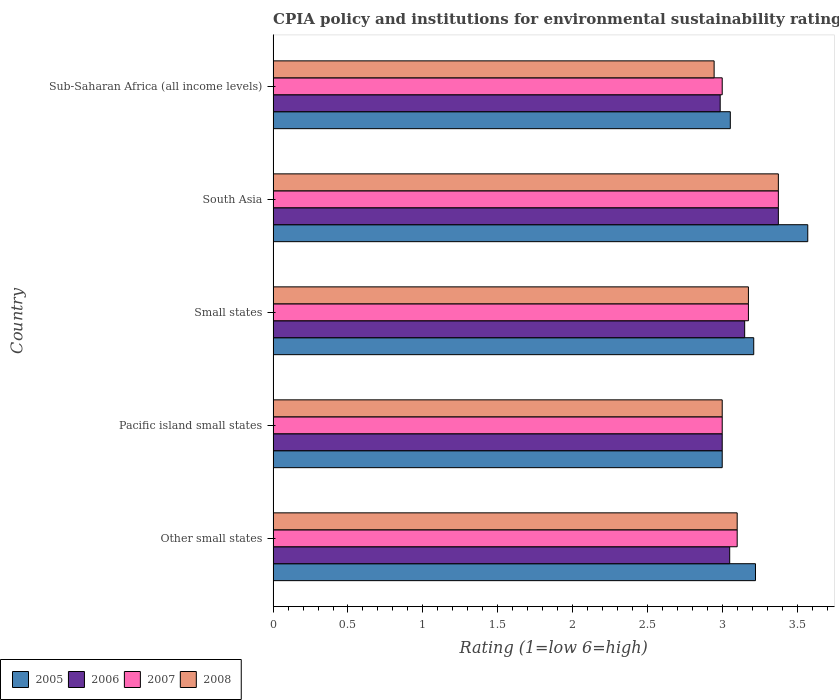How many different coloured bars are there?
Ensure brevity in your answer.  4. How many groups of bars are there?
Ensure brevity in your answer.  5. How many bars are there on the 5th tick from the top?
Provide a short and direct response. 4. In how many cases, is the number of bars for a given country not equal to the number of legend labels?
Your answer should be very brief. 0. What is the CPIA rating in 2007 in South Asia?
Your answer should be compact. 3.38. Across all countries, what is the maximum CPIA rating in 2008?
Offer a terse response. 3.38. Across all countries, what is the minimum CPIA rating in 2008?
Offer a very short reply. 2.95. In which country was the CPIA rating in 2008 minimum?
Offer a very short reply. Sub-Saharan Africa (all income levels). What is the total CPIA rating in 2006 in the graph?
Provide a short and direct response. 15.56. What is the difference between the CPIA rating in 2005 in Small states and that in Sub-Saharan Africa (all income levels)?
Give a very brief answer. 0.16. What is the difference between the CPIA rating in 2008 in South Asia and the CPIA rating in 2007 in Small states?
Provide a succinct answer. 0.2. What is the average CPIA rating in 2005 per country?
Your response must be concise. 3.21. What is the difference between the CPIA rating in 2005 and CPIA rating in 2008 in South Asia?
Keep it short and to the point. 0.2. What is the ratio of the CPIA rating in 2005 in Other small states to that in South Asia?
Offer a terse response. 0.9. Is the CPIA rating in 2006 in Pacific island small states less than that in Small states?
Offer a very short reply. Yes. What is the difference between the highest and the second highest CPIA rating in 2007?
Provide a succinct answer. 0.2. What is the difference between the highest and the lowest CPIA rating in 2005?
Give a very brief answer. 0.57. What does the 4th bar from the bottom in Pacific island small states represents?
Keep it short and to the point. 2008. What is the difference between two consecutive major ticks on the X-axis?
Ensure brevity in your answer.  0.5. Are the values on the major ticks of X-axis written in scientific E-notation?
Provide a short and direct response. No. Where does the legend appear in the graph?
Provide a short and direct response. Bottom left. How many legend labels are there?
Your response must be concise. 4. How are the legend labels stacked?
Make the answer very short. Horizontal. What is the title of the graph?
Provide a short and direct response. CPIA policy and institutions for environmental sustainability rating. What is the label or title of the X-axis?
Keep it short and to the point. Rating (1=low 6=high). What is the label or title of the Y-axis?
Your answer should be very brief. Country. What is the Rating (1=low 6=high) of 2005 in Other small states?
Provide a succinct answer. 3.22. What is the Rating (1=low 6=high) of 2006 in Other small states?
Your response must be concise. 3.05. What is the Rating (1=low 6=high) in 2006 in Pacific island small states?
Offer a very short reply. 3. What is the Rating (1=low 6=high) in 2005 in Small states?
Offer a terse response. 3.21. What is the Rating (1=low 6=high) of 2006 in Small states?
Your response must be concise. 3.15. What is the Rating (1=low 6=high) in 2007 in Small states?
Keep it short and to the point. 3.17. What is the Rating (1=low 6=high) of 2008 in Small states?
Your response must be concise. 3.17. What is the Rating (1=low 6=high) of 2005 in South Asia?
Your answer should be very brief. 3.57. What is the Rating (1=low 6=high) in 2006 in South Asia?
Offer a very short reply. 3.38. What is the Rating (1=low 6=high) in 2007 in South Asia?
Your response must be concise. 3.38. What is the Rating (1=low 6=high) of 2008 in South Asia?
Your response must be concise. 3.38. What is the Rating (1=low 6=high) in 2005 in Sub-Saharan Africa (all income levels)?
Offer a terse response. 3.05. What is the Rating (1=low 6=high) in 2006 in Sub-Saharan Africa (all income levels)?
Keep it short and to the point. 2.99. What is the Rating (1=low 6=high) in 2008 in Sub-Saharan Africa (all income levels)?
Give a very brief answer. 2.95. Across all countries, what is the maximum Rating (1=low 6=high) of 2005?
Your answer should be very brief. 3.57. Across all countries, what is the maximum Rating (1=low 6=high) in 2006?
Offer a terse response. 3.38. Across all countries, what is the maximum Rating (1=low 6=high) in 2007?
Provide a succinct answer. 3.38. Across all countries, what is the maximum Rating (1=low 6=high) of 2008?
Offer a terse response. 3.38. Across all countries, what is the minimum Rating (1=low 6=high) of 2006?
Offer a terse response. 2.99. Across all countries, what is the minimum Rating (1=low 6=high) of 2007?
Make the answer very short. 3. Across all countries, what is the minimum Rating (1=low 6=high) in 2008?
Provide a short and direct response. 2.95. What is the total Rating (1=low 6=high) of 2005 in the graph?
Provide a succinct answer. 16.06. What is the total Rating (1=low 6=high) in 2006 in the graph?
Offer a terse response. 15.56. What is the total Rating (1=low 6=high) of 2007 in the graph?
Your answer should be compact. 15.65. What is the total Rating (1=low 6=high) in 2008 in the graph?
Your answer should be very brief. 15.6. What is the difference between the Rating (1=low 6=high) of 2005 in Other small states and that in Pacific island small states?
Your response must be concise. 0.22. What is the difference between the Rating (1=low 6=high) in 2006 in Other small states and that in Pacific island small states?
Offer a terse response. 0.05. What is the difference between the Rating (1=low 6=high) in 2008 in Other small states and that in Pacific island small states?
Keep it short and to the point. 0.1. What is the difference between the Rating (1=low 6=high) of 2005 in Other small states and that in Small states?
Your response must be concise. 0.01. What is the difference between the Rating (1=low 6=high) of 2007 in Other small states and that in Small states?
Your answer should be compact. -0.07. What is the difference between the Rating (1=low 6=high) of 2008 in Other small states and that in Small states?
Make the answer very short. -0.07. What is the difference between the Rating (1=low 6=high) in 2005 in Other small states and that in South Asia?
Ensure brevity in your answer.  -0.35. What is the difference between the Rating (1=low 6=high) of 2006 in Other small states and that in South Asia?
Provide a short and direct response. -0.33. What is the difference between the Rating (1=low 6=high) in 2007 in Other small states and that in South Asia?
Your answer should be compact. -0.28. What is the difference between the Rating (1=low 6=high) of 2008 in Other small states and that in South Asia?
Your answer should be very brief. -0.28. What is the difference between the Rating (1=low 6=high) in 2005 in Other small states and that in Sub-Saharan Africa (all income levels)?
Provide a succinct answer. 0.17. What is the difference between the Rating (1=low 6=high) of 2006 in Other small states and that in Sub-Saharan Africa (all income levels)?
Provide a short and direct response. 0.06. What is the difference between the Rating (1=low 6=high) in 2008 in Other small states and that in Sub-Saharan Africa (all income levels)?
Offer a terse response. 0.15. What is the difference between the Rating (1=low 6=high) of 2005 in Pacific island small states and that in Small states?
Give a very brief answer. -0.21. What is the difference between the Rating (1=low 6=high) of 2007 in Pacific island small states and that in Small states?
Give a very brief answer. -0.17. What is the difference between the Rating (1=low 6=high) in 2008 in Pacific island small states and that in Small states?
Provide a succinct answer. -0.17. What is the difference between the Rating (1=low 6=high) in 2005 in Pacific island small states and that in South Asia?
Offer a very short reply. -0.57. What is the difference between the Rating (1=low 6=high) in 2006 in Pacific island small states and that in South Asia?
Offer a terse response. -0.38. What is the difference between the Rating (1=low 6=high) of 2007 in Pacific island small states and that in South Asia?
Your answer should be very brief. -0.38. What is the difference between the Rating (1=low 6=high) of 2008 in Pacific island small states and that in South Asia?
Ensure brevity in your answer.  -0.38. What is the difference between the Rating (1=low 6=high) in 2005 in Pacific island small states and that in Sub-Saharan Africa (all income levels)?
Provide a succinct answer. -0.05. What is the difference between the Rating (1=low 6=high) in 2006 in Pacific island small states and that in Sub-Saharan Africa (all income levels)?
Your response must be concise. 0.01. What is the difference between the Rating (1=low 6=high) of 2008 in Pacific island small states and that in Sub-Saharan Africa (all income levels)?
Provide a short and direct response. 0.05. What is the difference between the Rating (1=low 6=high) in 2005 in Small states and that in South Asia?
Provide a succinct answer. -0.36. What is the difference between the Rating (1=low 6=high) of 2006 in Small states and that in South Asia?
Keep it short and to the point. -0.23. What is the difference between the Rating (1=low 6=high) of 2008 in Small states and that in South Asia?
Provide a succinct answer. -0.2. What is the difference between the Rating (1=low 6=high) of 2005 in Small states and that in Sub-Saharan Africa (all income levels)?
Provide a succinct answer. 0.16. What is the difference between the Rating (1=low 6=high) of 2006 in Small states and that in Sub-Saharan Africa (all income levels)?
Your response must be concise. 0.16. What is the difference between the Rating (1=low 6=high) in 2007 in Small states and that in Sub-Saharan Africa (all income levels)?
Your response must be concise. 0.17. What is the difference between the Rating (1=low 6=high) of 2008 in Small states and that in Sub-Saharan Africa (all income levels)?
Ensure brevity in your answer.  0.23. What is the difference between the Rating (1=low 6=high) in 2005 in South Asia and that in Sub-Saharan Africa (all income levels)?
Make the answer very short. 0.52. What is the difference between the Rating (1=low 6=high) in 2006 in South Asia and that in Sub-Saharan Africa (all income levels)?
Offer a terse response. 0.39. What is the difference between the Rating (1=low 6=high) of 2008 in South Asia and that in Sub-Saharan Africa (all income levels)?
Provide a succinct answer. 0.43. What is the difference between the Rating (1=low 6=high) of 2005 in Other small states and the Rating (1=low 6=high) of 2006 in Pacific island small states?
Offer a very short reply. 0.22. What is the difference between the Rating (1=low 6=high) in 2005 in Other small states and the Rating (1=low 6=high) in 2007 in Pacific island small states?
Offer a very short reply. 0.22. What is the difference between the Rating (1=low 6=high) in 2005 in Other small states and the Rating (1=low 6=high) in 2008 in Pacific island small states?
Keep it short and to the point. 0.22. What is the difference between the Rating (1=low 6=high) in 2005 in Other small states and the Rating (1=low 6=high) in 2006 in Small states?
Your response must be concise. 0.07. What is the difference between the Rating (1=low 6=high) in 2005 in Other small states and the Rating (1=low 6=high) in 2007 in Small states?
Offer a terse response. 0.05. What is the difference between the Rating (1=low 6=high) of 2005 in Other small states and the Rating (1=low 6=high) of 2008 in Small states?
Provide a succinct answer. 0.05. What is the difference between the Rating (1=low 6=high) of 2006 in Other small states and the Rating (1=low 6=high) of 2007 in Small states?
Your answer should be compact. -0.12. What is the difference between the Rating (1=low 6=high) of 2006 in Other small states and the Rating (1=low 6=high) of 2008 in Small states?
Make the answer very short. -0.12. What is the difference between the Rating (1=low 6=high) of 2007 in Other small states and the Rating (1=low 6=high) of 2008 in Small states?
Your answer should be compact. -0.07. What is the difference between the Rating (1=low 6=high) of 2005 in Other small states and the Rating (1=low 6=high) of 2006 in South Asia?
Offer a very short reply. -0.15. What is the difference between the Rating (1=low 6=high) of 2005 in Other small states and the Rating (1=low 6=high) of 2007 in South Asia?
Ensure brevity in your answer.  -0.15. What is the difference between the Rating (1=low 6=high) of 2005 in Other small states and the Rating (1=low 6=high) of 2008 in South Asia?
Give a very brief answer. -0.15. What is the difference between the Rating (1=low 6=high) in 2006 in Other small states and the Rating (1=low 6=high) in 2007 in South Asia?
Make the answer very short. -0.33. What is the difference between the Rating (1=low 6=high) in 2006 in Other small states and the Rating (1=low 6=high) in 2008 in South Asia?
Offer a very short reply. -0.33. What is the difference between the Rating (1=low 6=high) in 2007 in Other small states and the Rating (1=low 6=high) in 2008 in South Asia?
Your response must be concise. -0.28. What is the difference between the Rating (1=low 6=high) in 2005 in Other small states and the Rating (1=low 6=high) in 2006 in Sub-Saharan Africa (all income levels)?
Your answer should be very brief. 0.24. What is the difference between the Rating (1=low 6=high) of 2005 in Other small states and the Rating (1=low 6=high) of 2007 in Sub-Saharan Africa (all income levels)?
Give a very brief answer. 0.22. What is the difference between the Rating (1=low 6=high) of 2005 in Other small states and the Rating (1=low 6=high) of 2008 in Sub-Saharan Africa (all income levels)?
Ensure brevity in your answer.  0.28. What is the difference between the Rating (1=low 6=high) of 2006 in Other small states and the Rating (1=low 6=high) of 2007 in Sub-Saharan Africa (all income levels)?
Your response must be concise. 0.05. What is the difference between the Rating (1=low 6=high) in 2006 in Other small states and the Rating (1=low 6=high) in 2008 in Sub-Saharan Africa (all income levels)?
Give a very brief answer. 0.1. What is the difference between the Rating (1=low 6=high) of 2007 in Other small states and the Rating (1=low 6=high) of 2008 in Sub-Saharan Africa (all income levels)?
Offer a very short reply. 0.15. What is the difference between the Rating (1=low 6=high) of 2005 in Pacific island small states and the Rating (1=low 6=high) of 2006 in Small states?
Make the answer very short. -0.15. What is the difference between the Rating (1=low 6=high) in 2005 in Pacific island small states and the Rating (1=low 6=high) in 2007 in Small states?
Make the answer very short. -0.17. What is the difference between the Rating (1=low 6=high) in 2005 in Pacific island small states and the Rating (1=low 6=high) in 2008 in Small states?
Offer a very short reply. -0.17. What is the difference between the Rating (1=low 6=high) in 2006 in Pacific island small states and the Rating (1=low 6=high) in 2007 in Small states?
Give a very brief answer. -0.17. What is the difference between the Rating (1=low 6=high) in 2006 in Pacific island small states and the Rating (1=low 6=high) in 2008 in Small states?
Give a very brief answer. -0.17. What is the difference between the Rating (1=low 6=high) in 2007 in Pacific island small states and the Rating (1=low 6=high) in 2008 in Small states?
Your answer should be very brief. -0.17. What is the difference between the Rating (1=low 6=high) in 2005 in Pacific island small states and the Rating (1=low 6=high) in 2006 in South Asia?
Your answer should be compact. -0.38. What is the difference between the Rating (1=low 6=high) of 2005 in Pacific island small states and the Rating (1=low 6=high) of 2007 in South Asia?
Your answer should be compact. -0.38. What is the difference between the Rating (1=low 6=high) in 2005 in Pacific island small states and the Rating (1=low 6=high) in 2008 in South Asia?
Your answer should be very brief. -0.38. What is the difference between the Rating (1=low 6=high) of 2006 in Pacific island small states and the Rating (1=low 6=high) of 2007 in South Asia?
Offer a very short reply. -0.38. What is the difference between the Rating (1=low 6=high) in 2006 in Pacific island small states and the Rating (1=low 6=high) in 2008 in South Asia?
Provide a short and direct response. -0.38. What is the difference between the Rating (1=low 6=high) of 2007 in Pacific island small states and the Rating (1=low 6=high) of 2008 in South Asia?
Offer a terse response. -0.38. What is the difference between the Rating (1=low 6=high) in 2005 in Pacific island small states and the Rating (1=low 6=high) in 2006 in Sub-Saharan Africa (all income levels)?
Your response must be concise. 0.01. What is the difference between the Rating (1=low 6=high) of 2005 in Pacific island small states and the Rating (1=low 6=high) of 2007 in Sub-Saharan Africa (all income levels)?
Provide a succinct answer. 0. What is the difference between the Rating (1=low 6=high) of 2005 in Pacific island small states and the Rating (1=low 6=high) of 2008 in Sub-Saharan Africa (all income levels)?
Offer a terse response. 0.05. What is the difference between the Rating (1=low 6=high) in 2006 in Pacific island small states and the Rating (1=low 6=high) in 2008 in Sub-Saharan Africa (all income levels)?
Your answer should be very brief. 0.05. What is the difference between the Rating (1=low 6=high) of 2007 in Pacific island small states and the Rating (1=low 6=high) of 2008 in Sub-Saharan Africa (all income levels)?
Your answer should be compact. 0.05. What is the difference between the Rating (1=low 6=high) in 2005 in Small states and the Rating (1=low 6=high) in 2006 in South Asia?
Make the answer very short. -0.16. What is the difference between the Rating (1=low 6=high) in 2005 in Small states and the Rating (1=low 6=high) in 2007 in South Asia?
Make the answer very short. -0.16. What is the difference between the Rating (1=low 6=high) in 2005 in Small states and the Rating (1=low 6=high) in 2008 in South Asia?
Your response must be concise. -0.16. What is the difference between the Rating (1=low 6=high) in 2006 in Small states and the Rating (1=low 6=high) in 2007 in South Asia?
Your answer should be compact. -0.23. What is the difference between the Rating (1=low 6=high) of 2006 in Small states and the Rating (1=low 6=high) of 2008 in South Asia?
Provide a short and direct response. -0.23. What is the difference between the Rating (1=low 6=high) of 2005 in Small states and the Rating (1=low 6=high) of 2006 in Sub-Saharan Africa (all income levels)?
Make the answer very short. 0.22. What is the difference between the Rating (1=low 6=high) of 2005 in Small states and the Rating (1=low 6=high) of 2007 in Sub-Saharan Africa (all income levels)?
Provide a succinct answer. 0.21. What is the difference between the Rating (1=low 6=high) in 2005 in Small states and the Rating (1=low 6=high) in 2008 in Sub-Saharan Africa (all income levels)?
Your answer should be compact. 0.26. What is the difference between the Rating (1=low 6=high) of 2006 in Small states and the Rating (1=low 6=high) of 2007 in Sub-Saharan Africa (all income levels)?
Your response must be concise. 0.15. What is the difference between the Rating (1=low 6=high) in 2006 in Small states and the Rating (1=low 6=high) in 2008 in Sub-Saharan Africa (all income levels)?
Your answer should be very brief. 0.2. What is the difference between the Rating (1=low 6=high) of 2007 in Small states and the Rating (1=low 6=high) of 2008 in Sub-Saharan Africa (all income levels)?
Your answer should be very brief. 0.23. What is the difference between the Rating (1=low 6=high) in 2005 in South Asia and the Rating (1=low 6=high) in 2006 in Sub-Saharan Africa (all income levels)?
Offer a very short reply. 0.58. What is the difference between the Rating (1=low 6=high) of 2005 in South Asia and the Rating (1=low 6=high) of 2008 in Sub-Saharan Africa (all income levels)?
Offer a terse response. 0.63. What is the difference between the Rating (1=low 6=high) of 2006 in South Asia and the Rating (1=low 6=high) of 2008 in Sub-Saharan Africa (all income levels)?
Provide a short and direct response. 0.43. What is the difference between the Rating (1=low 6=high) in 2007 in South Asia and the Rating (1=low 6=high) in 2008 in Sub-Saharan Africa (all income levels)?
Provide a short and direct response. 0.43. What is the average Rating (1=low 6=high) in 2005 per country?
Make the answer very short. 3.21. What is the average Rating (1=low 6=high) in 2006 per country?
Offer a very short reply. 3.11. What is the average Rating (1=low 6=high) of 2007 per country?
Your answer should be compact. 3.13. What is the average Rating (1=low 6=high) of 2008 per country?
Make the answer very short. 3.12. What is the difference between the Rating (1=low 6=high) in 2005 and Rating (1=low 6=high) in 2006 in Other small states?
Ensure brevity in your answer.  0.17. What is the difference between the Rating (1=low 6=high) in 2005 and Rating (1=low 6=high) in 2007 in Other small states?
Provide a short and direct response. 0.12. What is the difference between the Rating (1=low 6=high) of 2005 and Rating (1=low 6=high) of 2008 in Other small states?
Your answer should be compact. 0.12. What is the difference between the Rating (1=low 6=high) of 2006 and Rating (1=low 6=high) of 2008 in Other small states?
Provide a short and direct response. -0.05. What is the difference between the Rating (1=low 6=high) in 2007 and Rating (1=low 6=high) in 2008 in Other small states?
Provide a succinct answer. 0. What is the difference between the Rating (1=low 6=high) of 2005 and Rating (1=low 6=high) of 2006 in Pacific island small states?
Offer a terse response. 0. What is the difference between the Rating (1=low 6=high) in 2005 and Rating (1=low 6=high) in 2008 in Pacific island small states?
Give a very brief answer. 0. What is the difference between the Rating (1=low 6=high) of 2006 and Rating (1=low 6=high) of 2007 in Pacific island small states?
Make the answer very short. 0. What is the difference between the Rating (1=low 6=high) in 2006 and Rating (1=low 6=high) in 2008 in Pacific island small states?
Keep it short and to the point. 0. What is the difference between the Rating (1=low 6=high) in 2005 and Rating (1=low 6=high) in 2006 in Small states?
Make the answer very short. 0.06. What is the difference between the Rating (1=low 6=high) of 2005 and Rating (1=low 6=high) of 2007 in Small states?
Your answer should be very brief. 0.04. What is the difference between the Rating (1=low 6=high) in 2005 and Rating (1=low 6=high) in 2008 in Small states?
Make the answer very short. 0.04. What is the difference between the Rating (1=low 6=high) of 2006 and Rating (1=low 6=high) of 2007 in Small states?
Offer a terse response. -0.03. What is the difference between the Rating (1=low 6=high) in 2006 and Rating (1=low 6=high) in 2008 in Small states?
Your answer should be very brief. -0.03. What is the difference between the Rating (1=low 6=high) of 2005 and Rating (1=low 6=high) of 2006 in South Asia?
Offer a terse response. 0.2. What is the difference between the Rating (1=low 6=high) in 2005 and Rating (1=low 6=high) in 2007 in South Asia?
Ensure brevity in your answer.  0.2. What is the difference between the Rating (1=low 6=high) of 2005 and Rating (1=low 6=high) of 2008 in South Asia?
Your answer should be very brief. 0.2. What is the difference between the Rating (1=low 6=high) in 2006 and Rating (1=low 6=high) in 2008 in South Asia?
Offer a terse response. 0. What is the difference between the Rating (1=low 6=high) of 2005 and Rating (1=low 6=high) of 2006 in Sub-Saharan Africa (all income levels)?
Keep it short and to the point. 0.07. What is the difference between the Rating (1=low 6=high) of 2005 and Rating (1=low 6=high) of 2007 in Sub-Saharan Africa (all income levels)?
Provide a short and direct response. 0.05. What is the difference between the Rating (1=low 6=high) in 2005 and Rating (1=low 6=high) in 2008 in Sub-Saharan Africa (all income levels)?
Ensure brevity in your answer.  0.11. What is the difference between the Rating (1=low 6=high) of 2006 and Rating (1=low 6=high) of 2007 in Sub-Saharan Africa (all income levels)?
Make the answer very short. -0.01. What is the difference between the Rating (1=low 6=high) in 2006 and Rating (1=low 6=high) in 2008 in Sub-Saharan Africa (all income levels)?
Provide a succinct answer. 0.04. What is the difference between the Rating (1=low 6=high) of 2007 and Rating (1=low 6=high) of 2008 in Sub-Saharan Africa (all income levels)?
Provide a succinct answer. 0.05. What is the ratio of the Rating (1=low 6=high) in 2005 in Other small states to that in Pacific island small states?
Offer a terse response. 1.07. What is the ratio of the Rating (1=low 6=high) of 2006 in Other small states to that in Pacific island small states?
Your answer should be compact. 1.02. What is the ratio of the Rating (1=low 6=high) of 2006 in Other small states to that in Small states?
Your answer should be compact. 0.97. What is the ratio of the Rating (1=low 6=high) in 2007 in Other small states to that in Small states?
Ensure brevity in your answer.  0.98. What is the ratio of the Rating (1=low 6=high) of 2008 in Other small states to that in Small states?
Offer a terse response. 0.98. What is the ratio of the Rating (1=low 6=high) in 2005 in Other small states to that in South Asia?
Offer a very short reply. 0.9. What is the ratio of the Rating (1=low 6=high) in 2006 in Other small states to that in South Asia?
Your answer should be very brief. 0.9. What is the ratio of the Rating (1=low 6=high) in 2007 in Other small states to that in South Asia?
Your answer should be very brief. 0.92. What is the ratio of the Rating (1=low 6=high) in 2008 in Other small states to that in South Asia?
Ensure brevity in your answer.  0.92. What is the ratio of the Rating (1=low 6=high) of 2005 in Other small states to that in Sub-Saharan Africa (all income levels)?
Provide a succinct answer. 1.06. What is the ratio of the Rating (1=low 6=high) in 2006 in Other small states to that in Sub-Saharan Africa (all income levels)?
Provide a succinct answer. 1.02. What is the ratio of the Rating (1=low 6=high) in 2007 in Other small states to that in Sub-Saharan Africa (all income levels)?
Offer a terse response. 1.03. What is the ratio of the Rating (1=low 6=high) of 2008 in Other small states to that in Sub-Saharan Africa (all income levels)?
Offer a very short reply. 1.05. What is the ratio of the Rating (1=low 6=high) in 2005 in Pacific island small states to that in Small states?
Your answer should be compact. 0.93. What is the ratio of the Rating (1=low 6=high) in 2006 in Pacific island small states to that in Small states?
Offer a very short reply. 0.95. What is the ratio of the Rating (1=low 6=high) of 2007 in Pacific island small states to that in Small states?
Keep it short and to the point. 0.94. What is the ratio of the Rating (1=low 6=high) of 2008 in Pacific island small states to that in Small states?
Provide a short and direct response. 0.94. What is the ratio of the Rating (1=low 6=high) in 2005 in Pacific island small states to that in South Asia?
Give a very brief answer. 0.84. What is the ratio of the Rating (1=low 6=high) in 2006 in Pacific island small states to that in South Asia?
Your answer should be compact. 0.89. What is the ratio of the Rating (1=low 6=high) of 2007 in Pacific island small states to that in South Asia?
Your answer should be compact. 0.89. What is the ratio of the Rating (1=low 6=high) in 2005 in Pacific island small states to that in Sub-Saharan Africa (all income levels)?
Ensure brevity in your answer.  0.98. What is the ratio of the Rating (1=low 6=high) of 2007 in Pacific island small states to that in Sub-Saharan Africa (all income levels)?
Give a very brief answer. 1. What is the ratio of the Rating (1=low 6=high) in 2008 in Pacific island small states to that in Sub-Saharan Africa (all income levels)?
Ensure brevity in your answer.  1.02. What is the ratio of the Rating (1=low 6=high) in 2005 in Small states to that in South Asia?
Offer a very short reply. 0.9. What is the ratio of the Rating (1=low 6=high) in 2006 in Small states to that in South Asia?
Provide a succinct answer. 0.93. What is the ratio of the Rating (1=low 6=high) of 2007 in Small states to that in South Asia?
Make the answer very short. 0.94. What is the ratio of the Rating (1=low 6=high) in 2008 in Small states to that in South Asia?
Provide a short and direct response. 0.94. What is the ratio of the Rating (1=low 6=high) of 2005 in Small states to that in Sub-Saharan Africa (all income levels)?
Offer a terse response. 1.05. What is the ratio of the Rating (1=low 6=high) of 2006 in Small states to that in Sub-Saharan Africa (all income levels)?
Your answer should be very brief. 1.05. What is the ratio of the Rating (1=low 6=high) of 2007 in Small states to that in Sub-Saharan Africa (all income levels)?
Ensure brevity in your answer.  1.06. What is the ratio of the Rating (1=low 6=high) in 2008 in Small states to that in Sub-Saharan Africa (all income levels)?
Offer a terse response. 1.08. What is the ratio of the Rating (1=low 6=high) in 2005 in South Asia to that in Sub-Saharan Africa (all income levels)?
Keep it short and to the point. 1.17. What is the ratio of the Rating (1=low 6=high) in 2006 in South Asia to that in Sub-Saharan Africa (all income levels)?
Offer a terse response. 1.13. What is the ratio of the Rating (1=low 6=high) of 2007 in South Asia to that in Sub-Saharan Africa (all income levels)?
Make the answer very short. 1.12. What is the ratio of the Rating (1=low 6=high) in 2008 in South Asia to that in Sub-Saharan Africa (all income levels)?
Your answer should be compact. 1.15. What is the difference between the highest and the second highest Rating (1=low 6=high) in 2005?
Offer a terse response. 0.35. What is the difference between the highest and the second highest Rating (1=low 6=high) of 2006?
Ensure brevity in your answer.  0.23. What is the difference between the highest and the second highest Rating (1=low 6=high) of 2007?
Your response must be concise. 0.2. What is the difference between the highest and the second highest Rating (1=low 6=high) of 2008?
Make the answer very short. 0.2. What is the difference between the highest and the lowest Rating (1=low 6=high) of 2005?
Give a very brief answer. 0.57. What is the difference between the highest and the lowest Rating (1=low 6=high) of 2006?
Make the answer very short. 0.39. What is the difference between the highest and the lowest Rating (1=low 6=high) of 2008?
Provide a succinct answer. 0.43. 